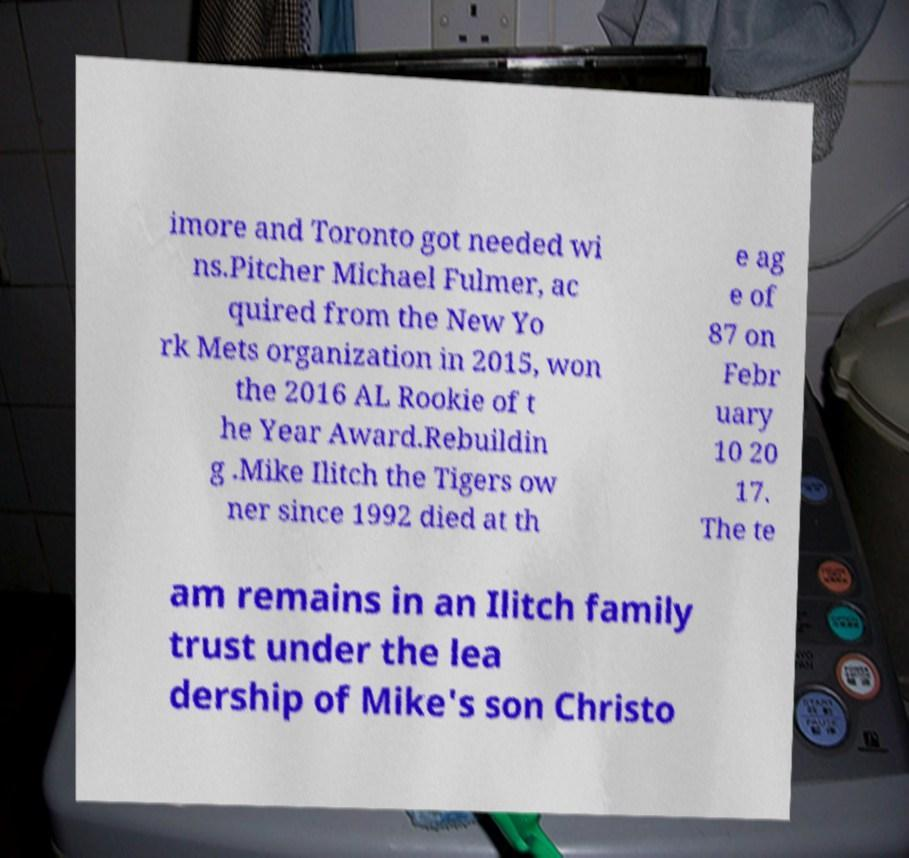Can you read and provide the text displayed in the image?This photo seems to have some interesting text. Can you extract and type it out for me? imore and Toronto got needed wi ns.Pitcher Michael Fulmer, ac quired from the New Yo rk Mets organization in 2015, won the 2016 AL Rookie of t he Year Award.Rebuildin g .Mike Ilitch the Tigers ow ner since 1992 died at th e ag e of 87 on Febr uary 10 20 17. The te am remains in an Ilitch family trust under the lea dership of Mike's son Christo 